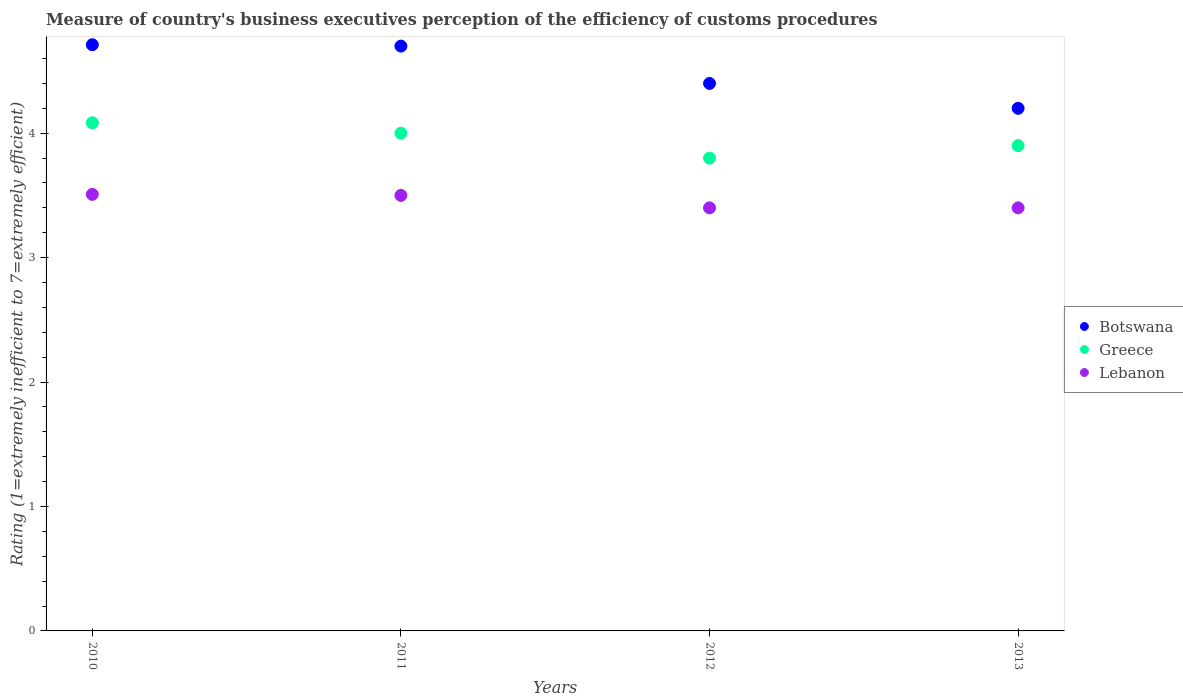How many different coloured dotlines are there?
Your response must be concise. 3. Is the number of dotlines equal to the number of legend labels?
Offer a terse response. Yes. Across all years, what is the maximum rating of the efficiency of customs procedure in Botswana?
Offer a terse response. 4.71. Across all years, what is the minimum rating of the efficiency of customs procedure in Lebanon?
Provide a short and direct response. 3.4. In which year was the rating of the efficiency of customs procedure in Greece minimum?
Ensure brevity in your answer.  2012. What is the total rating of the efficiency of customs procedure in Botswana in the graph?
Provide a succinct answer. 18.01. What is the difference between the rating of the efficiency of customs procedure in Greece in 2011 and that in 2013?
Keep it short and to the point. 0.1. What is the difference between the rating of the efficiency of customs procedure in Botswana in 2011 and the rating of the efficiency of customs procedure in Lebanon in 2010?
Make the answer very short. 1.19. What is the average rating of the efficiency of customs procedure in Botswana per year?
Make the answer very short. 4.5. In the year 2010, what is the difference between the rating of the efficiency of customs procedure in Lebanon and rating of the efficiency of customs procedure in Greece?
Offer a terse response. -0.58. What is the ratio of the rating of the efficiency of customs procedure in Lebanon in 2011 to that in 2013?
Give a very brief answer. 1.03. Is the rating of the efficiency of customs procedure in Botswana in 2011 less than that in 2012?
Make the answer very short. No. What is the difference between the highest and the second highest rating of the efficiency of customs procedure in Botswana?
Your answer should be compact. 0.01. What is the difference between the highest and the lowest rating of the efficiency of customs procedure in Lebanon?
Give a very brief answer. 0.11. Does the rating of the efficiency of customs procedure in Botswana monotonically increase over the years?
Your response must be concise. No. How many dotlines are there?
Provide a succinct answer. 3. Are the values on the major ticks of Y-axis written in scientific E-notation?
Ensure brevity in your answer.  No. Does the graph contain any zero values?
Your answer should be very brief. No. Where does the legend appear in the graph?
Provide a short and direct response. Center right. What is the title of the graph?
Ensure brevity in your answer.  Measure of country's business executives perception of the efficiency of customs procedures. What is the label or title of the Y-axis?
Give a very brief answer. Rating (1=extremely inefficient to 7=extremely efficient). What is the Rating (1=extremely inefficient to 7=extremely efficient) of Botswana in 2010?
Keep it short and to the point. 4.71. What is the Rating (1=extremely inefficient to 7=extremely efficient) of Greece in 2010?
Give a very brief answer. 4.08. What is the Rating (1=extremely inefficient to 7=extremely efficient) in Lebanon in 2010?
Offer a very short reply. 3.51. What is the Rating (1=extremely inefficient to 7=extremely efficient) in Greece in 2011?
Your answer should be compact. 4. What is the Rating (1=extremely inefficient to 7=extremely efficient) in Botswana in 2012?
Your answer should be very brief. 4.4. What is the Rating (1=extremely inefficient to 7=extremely efficient) of Greece in 2012?
Offer a terse response. 3.8. What is the Rating (1=extremely inefficient to 7=extremely efficient) of Lebanon in 2013?
Your answer should be compact. 3.4. Across all years, what is the maximum Rating (1=extremely inefficient to 7=extremely efficient) of Botswana?
Provide a short and direct response. 4.71. Across all years, what is the maximum Rating (1=extremely inefficient to 7=extremely efficient) in Greece?
Provide a succinct answer. 4.08. Across all years, what is the maximum Rating (1=extremely inefficient to 7=extremely efficient) in Lebanon?
Ensure brevity in your answer.  3.51. Across all years, what is the minimum Rating (1=extremely inefficient to 7=extremely efficient) in Botswana?
Your response must be concise. 4.2. What is the total Rating (1=extremely inefficient to 7=extremely efficient) of Botswana in the graph?
Your answer should be very brief. 18.01. What is the total Rating (1=extremely inefficient to 7=extremely efficient) of Greece in the graph?
Your response must be concise. 15.78. What is the total Rating (1=extremely inefficient to 7=extremely efficient) of Lebanon in the graph?
Provide a short and direct response. 13.81. What is the difference between the Rating (1=extremely inefficient to 7=extremely efficient) of Botswana in 2010 and that in 2011?
Ensure brevity in your answer.  0.01. What is the difference between the Rating (1=extremely inefficient to 7=extremely efficient) in Greece in 2010 and that in 2011?
Ensure brevity in your answer.  0.08. What is the difference between the Rating (1=extremely inefficient to 7=extremely efficient) in Lebanon in 2010 and that in 2011?
Offer a very short reply. 0.01. What is the difference between the Rating (1=extremely inefficient to 7=extremely efficient) of Botswana in 2010 and that in 2012?
Keep it short and to the point. 0.31. What is the difference between the Rating (1=extremely inefficient to 7=extremely efficient) in Greece in 2010 and that in 2012?
Make the answer very short. 0.28. What is the difference between the Rating (1=extremely inefficient to 7=extremely efficient) in Lebanon in 2010 and that in 2012?
Your answer should be very brief. 0.11. What is the difference between the Rating (1=extremely inefficient to 7=extremely efficient) of Botswana in 2010 and that in 2013?
Your response must be concise. 0.51. What is the difference between the Rating (1=extremely inefficient to 7=extremely efficient) of Greece in 2010 and that in 2013?
Your answer should be very brief. 0.18. What is the difference between the Rating (1=extremely inefficient to 7=extremely efficient) of Lebanon in 2010 and that in 2013?
Provide a short and direct response. 0.11. What is the difference between the Rating (1=extremely inefficient to 7=extremely efficient) in Botswana in 2011 and that in 2012?
Offer a very short reply. 0.3. What is the difference between the Rating (1=extremely inefficient to 7=extremely efficient) in Greece in 2011 and that in 2012?
Ensure brevity in your answer.  0.2. What is the difference between the Rating (1=extremely inefficient to 7=extremely efficient) in Lebanon in 2011 and that in 2012?
Keep it short and to the point. 0.1. What is the difference between the Rating (1=extremely inefficient to 7=extremely efficient) of Lebanon in 2011 and that in 2013?
Ensure brevity in your answer.  0.1. What is the difference between the Rating (1=extremely inefficient to 7=extremely efficient) in Botswana in 2012 and that in 2013?
Give a very brief answer. 0.2. What is the difference between the Rating (1=extremely inefficient to 7=extremely efficient) in Botswana in 2010 and the Rating (1=extremely inefficient to 7=extremely efficient) in Greece in 2011?
Your answer should be compact. 0.71. What is the difference between the Rating (1=extremely inefficient to 7=extremely efficient) of Botswana in 2010 and the Rating (1=extremely inefficient to 7=extremely efficient) of Lebanon in 2011?
Keep it short and to the point. 1.21. What is the difference between the Rating (1=extremely inefficient to 7=extremely efficient) in Greece in 2010 and the Rating (1=extremely inefficient to 7=extremely efficient) in Lebanon in 2011?
Your answer should be compact. 0.58. What is the difference between the Rating (1=extremely inefficient to 7=extremely efficient) in Botswana in 2010 and the Rating (1=extremely inefficient to 7=extremely efficient) in Greece in 2012?
Ensure brevity in your answer.  0.91. What is the difference between the Rating (1=extremely inefficient to 7=extremely efficient) in Botswana in 2010 and the Rating (1=extremely inefficient to 7=extremely efficient) in Lebanon in 2012?
Your answer should be compact. 1.31. What is the difference between the Rating (1=extremely inefficient to 7=extremely efficient) in Greece in 2010 and the Rating (1=extremely inefficient to 7=extremely efficient) in Lebanon in 2012?
Make the answer very short. 0.68. What is the difference between the Rating (1=extremely inefficient to 7=extremely efficient) of Botswana in 2010 and the Rating (1=extremely inefficient to 7=extremely efficient) of Greece in 2013?
Give a very brief answer. 0.81. What is the difference between the Rating (1=extremely inefficient to 7=extremely efficient) in Botswana in 2010 and the Rating (1=extremely inefficient to 7=extremely efficient) in Lebanon in 2013?
Offer a very short reply. 1.31. What is the difference between the Rating (1=extremely inefficient to 7=extremely efficient) of Greece in 2010 and the Rating (1=extremely inefficient to 7=extremely efficient) of Lebanon in 2013?
Offer a very short reply. 0.68. What is the difference between the Rating (1=extremely inefficient to 7=extremely efficient) of Greece in 2011 and the Rating (1=extremely inefficient to 7=extremely efficient) of Lebanon in 2012?
Ensure brevity in your answer.  0.6. What is the difference between the Rating (1=extremely inefficient to 7=extremely efficient) in Botswana in 2011 and the Rating (1=extremely inefficient to 7=extremely efficient) in Greece in 2013?
Provide a succinct answer. 0.8. What is the difference between the Rating (1=extremely inefficient to 7=extremely efficient) in Botswana in 2011 and the Rating (1=extremely inefficient to 7=extremely efficient) in Lebanon in 2013?
Your answer should be compact. 1.3. What is the difference between the Rating (1=extremely inefficient to 7=extremely efficient) in Greece in 2011 and the Rating (1=extremely inefficient to 7=extremely efficient) in Lebanon in 2013?
Provide a short and direct response. 0.6. What is the difference between the Rating (1=extremely inefficient to 7=extremely efficient) of Botswana in 2012 and the Rating (1=extremely inefficient to 7=extremely efficient) of Greece in 2013?
Give a very brief answer. 0.5. What is the difference between the Rating (1=extremely inefficient to 7=extremely efficient) of Botswana in 2012 and the Rating (1=extremely inefficient to 7=extremely efficient) of Lebanon in 2013?
Make the answer very short. 1. What is the average Rating (1=extremely inefficient to 7=extremely efficient) of Botswana per year?
Offer a terse response. 4.5. What is the average Rating (1=extremely inefficient to 7=extremely efficient) in Greece per year?
Make the answer very short. 3.95. What is the average Rating (1=extremely inefficient to 7=extremely efficient) in Lebanon per year?
Provide a short and direct response. 3.45. In the year 2010, what is the difference between the Rating (1=extremely inefficient to 7=extremely efficient) of Botswana and Rating (1=extremely inefficient to 7=extremely efficient) of Greece?
Give a very brief answer. 0.63. In the year 2010, what is the difference between the Rating (1=extremely inefficient to 7=extremely efficient) of Botswana and Rating (1=extremely inefficient to 7=extremely efficient) of Lebanon?
Make the answer very short. 1.2. In the year 2010, what is the difference between the Rating (1=extremely inefficient to 7=extremely efficient) of Greece and Rating (1=extremely inefficient to 7=extremely efficient) of Lebanon?
Your response must be concise. 0.58. In the year 2011, what is the difference between the Rating (1=extremely inefficient to 7=extremely efficient) of Botswana and Rating (1=extremely inefficient to 7=extremely efficient) of Greece?
Offer a terse response. 0.7. In the year 2011, what is the difference between the Rating (1=extremely inefficient to 7=extremely efficient) of Botswana and Rating (1=extremely inefficient to 7=extremely efficient) of Lebanon?
Make the answer very short. 1.2. In the year 2013, what is the difference between the Rating (1=extremely inefficient to 7=extremely efficient) in Botswana and Rating (1=extremely inefficient to 7=extremely efficient) in Greece?
Ensure brevity in your answer.  0.3. What is the ratio of the Rating (1=extremely inefficient to 7=extremely efficient) of Botswana in 2010 to that in 2011?
Give a very brief answer. 1. What is the ratio of the Rating (1=extremely inefficient to 7=extremely efficient) in Greece in 2010 to that in 2011?
Ensure brevity in your answer.  1.02. What is the ratio of the Rating (1=extremely inefficient to 7=extremely efficient) in Lebanon in 2010 to that in 2011?
Provide a succinct answer. 1. What is the ratio of the Rating (1=extremely inefficient to 7=extremely efficient) in Botswana in 2010 to that in 2012?
Your response must be concise. 1.07. What is the ratio of the Rating (1=extremely inefficient to 7=extremely efficient) in Greece in 2010 to that in 2012?
Your answer should be compact. 1.07. What is the ratio of the Rating (1=extremely inefficient to 7=extremely efficient) in Lebanon in 2010 to that in 2012?
Keep it short and to the point. 1.03. What is the ratio of the Rating (1=extremely inefficient to 7=extremely efficient) of Botswana in 2010 to that in 2013?
Ensure brevity in your answer.  1.12. What is the ratio of the Rating (1=extremely inefficient to 7=extremely efficient) of Greece in 2010 to that in 2013?
Give a very brief answer. 1.05. What is the ratio of the Rating (1=extremely inefficient to 7=extremely efficient) of Lebanon in 2010 to that in 2013?
Make the answer very short. 1.03. What is the ratio of the Rating (1=extremely inefficient to 7=extremely efficient) of Botswana in 2011 to that in 2012?
Your response must be concise. 1.07. What is the ratio of the Rating (1=extremely inefficient to 7=extremely efficient) in Greece in 2011 to that in 2012?
Your answer should be very brief. 1.05. What is the ratio of the Rating (1=extremely inefficient to 7=extremely efficient) of Lebanon in 2011 to that in 2012?
Offer a very short reply. 1.03. What is the ratio of the Rating (1=extremely inefficient to 7=extremely efficient) of Botswana in 2011 to that in 2013?
Your answer should be compact. 1.12. What is the ratio of the Rating (1=extremely inefficient to 7=extremely efficient) of Greece in 2011 to that in 2013?
Ensure brevity in your answer.  1.03. What is the ratio of the Rating (1=extremely inefficient to 7=extremely efficient) of Lebanon in 2011 to that in 2013?
Your answer should be very brief. 1.03. What is the ratio of the Rating (1=extremely inefficient to 7=extremely efficient) of Botswana in 2012 to that in 2013?
Give a very brief answer. 1.05. What is the ratio of the Rating (1=extremely inefficient to 7=extremely efficient) of Greece in 2012 to that in 2013?
Ensure brevity in your answer.  0.97. What is the difference between the highest and the second highest Rating (1=extremely inefficient to 7=extremely efficient) of Botswana?
Your answer should be compact. 0.01. What is the difference between the highest and the second highest Rating (1=extremely inefficient to 7=extremely efficient) in Greece?
Keep it short and to the point. 0.08. What is the difference between the highest and the second highest Rating (1=extremely inefficient to 7=extremely efficient) in Lebanon?
Keep it short and to the point. 0.01. What is the difference between the highest and the lowest Rating (1=extremely inefficient to 7=extremely efficient) in Botswana?
Your answer should be very brief. 0.51. What is the difference between the highest and the lowest Rating (1=extremely inefficient to 7=extremely efficient) of Greece?
Your answer should be very brief. 0.28. What is the difference between the highest and the lowest Rating (1=extremely inefficient to 7=extremely efficient) in Lebanon?
Give a very brief answer. 0.11. 